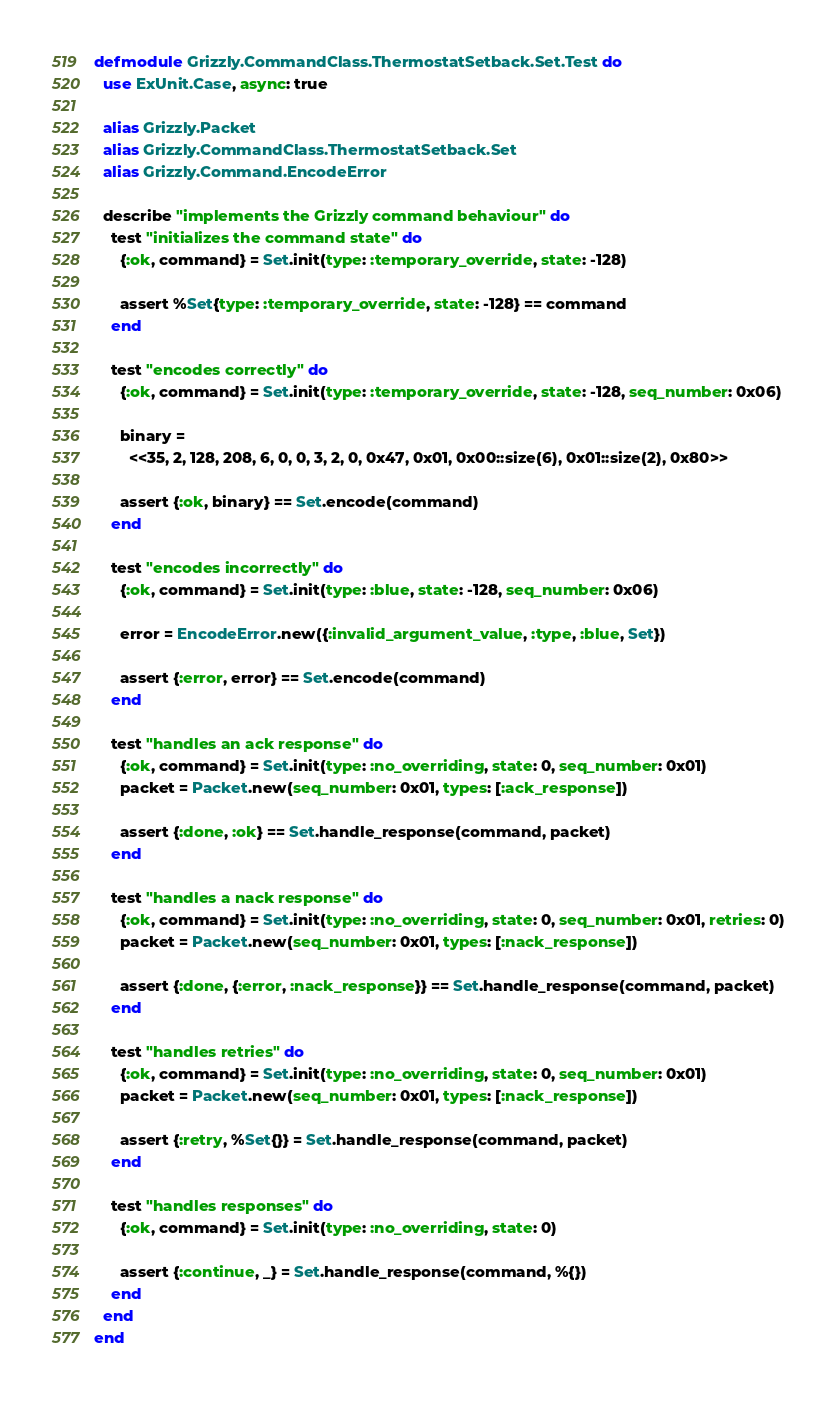Convert code to text. <code><loc_0><loc_0><loc_500><loc_500><_Elixir_>defmodule Grizzly.CommandClass.ThermostatSetback.Set.Test do
  use ExUnit.Case, async: true

  alias Grizzly.Packet
  alias Grizzly.CommandClass.ThermostatSetback.Set
  alias Grizzly.Command.EncodeError

  describe "implements the Grizzly command behaviour" do
    test "initializes the command state" do
      {:ok, command} = Set.init(type: :temporary_override, state: -128)

      assert %Set{type: :temporary_override, state: -128} == command
    end

    test "encodes correctly" do
      {:ok, command} = Set.init(type: :temporary_override, state: -128, seq_number: 0x06)

      binary =
        <<35, 2, 128, 208, 6, 0, 0, 3, 2, 0, 0x47, 0x01, 0x00::size(6), 0x01::size(2), 0x80>>

      assert {:ok, binary} == Set.encode(command)
    end

    test "encodes incorrectly" do
      {:ok, command} = Set.init(type: :blue, state: -128, seq_number: 0x06)

      error = EncodeError.new({:invalid_argument_value, :type, :blue, Set})

      assert {:error, error} == Set.encode(command)
    end

    test "handles an ack response" do
      {:ok, command} = Set.init(type: :no_overriding, state: 0, seq_number: 0x01)
      packet = Packet.new(seq_number: 0x01, types: [:ack_response])

      assert {:done, :ok} == Set.handle_response(command, packet)
    end

    test "handles a nack response" do
      {:ok, command} = Set.init(type: :no_overriding, state: 0, seq_number: 0x01, retries: 0)
      packet = Packet.new(seq_number: 0x01, types: [:nack_response])

      assert {:done, {:error, :nack_response}} == Set.handle_response(command, packet)
    end

    test "handles retries" do
      {:ok, command} = Set.init(type: :no_overriding, state: 0, seq_number: 0x01)
      packet = Packet.new(seq_number: 0x01, types: [:nack_response])

      assert {:retry, %Set{}} = Set.handle_response(command, packet)
    end

    test "handles responses" do
      {:ok, command} = Set.init(type: :no_overriding, state: 0)

      assert {:continue, _} = Set.handle_response(command, %{})
    end
  end
end
</code> 